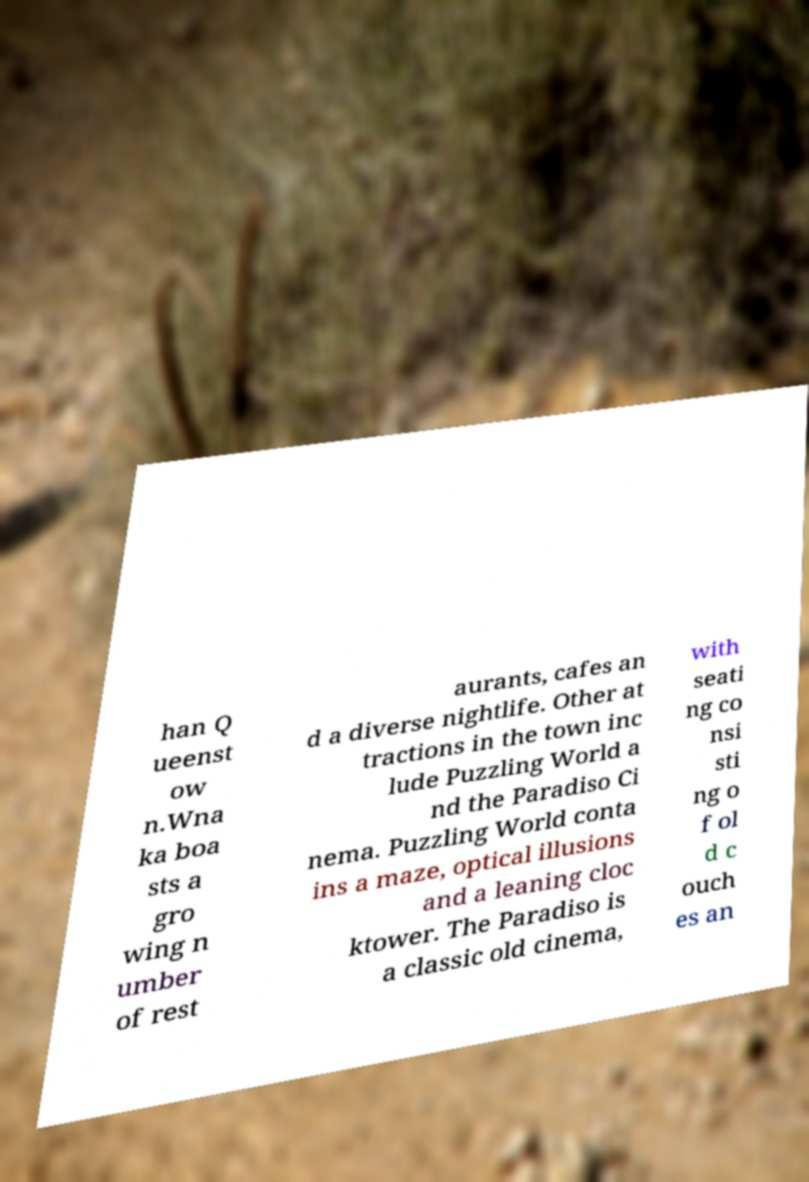Can you read and provide the text displayed in the image?This photo seems to have some interesting text. Can you extract and type it out for me? han Q ueenst ow n.Wna ka boa sts a gro wing n umber of rest aurants, cafes an d a diverse nightlife. Other at tractions in the town inc lude Puzzling World a nd the Paradiso Ci nema. Puzzling World conta ins a maze, optical illusions and a leaning cloc ktower. The Paradiso is a classic old cinema, with seati ng co nsi sti ng o f ol d c ouch es an 